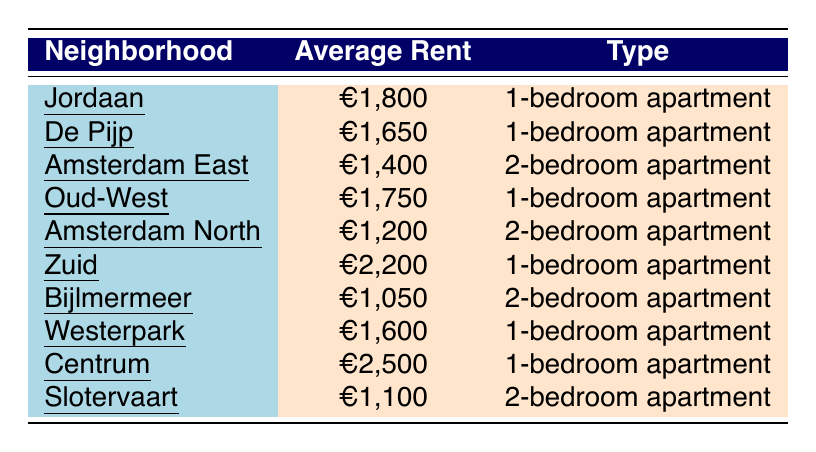What's the average rent for a 1-bedroom apartment in Jordaan? The table shows that the average rent for a 1-bedroom apartment in Jordaan is €1,800.
Answer: €1,800 Which neighborhood has the highest average rent for a 1-bedroom apartment? From the table, the neighborhood with the highest average rent for a 1-bedroom apartment is Centrum at €2,500.
Answer: Centrum What is the average rent of 2-bedroom apartments in Amsterdam North and Bijlmermeer? The average rent for a 2-bedroom apartment in Amsterdam North is €1,200, and in Bijlmermeer, it is €1,050. Adding these gives €1,200 + €1,050 = €2,250 for both, and dividing by 2 gives the average of €1,125.
Answer: €1,125 Is the average rent for a 1-bedroom apartment in De Pijp lower than in Oud-West? The average rent in De Pijp is €1,650 and in Oud-West is €1,750. Since €1,650 is less than €1,750, the statement is true.
Answer: Yes Which two neighborhoods have the lowest average rent for 2-bedroom apartments? The table shows that Bijlmermeer has the lowest rent at €1,050, and Slotervaart has €1,100. Comparing these prices, Bijlmermeer is lower than Slotervaart.
Answer: Bijlmermeer and Slotervaart What is the difference in average rent between the highest and lowest 1-bedroom apartment prices in the neighborhoods? The highest rent for a 1-bedroom apartment is in Centrum at €2,500, and the lowest is in De Pijp at €1,650. The difference is calculated as €2,500 - €1,650 = €850.
Answer: €850 How much more expensive is the average rent for a 1-bedroom apartment in Zuid compared to Amsterdam North's 2-bedroom apartment? The average rent for a 1-bedroom apartment in Zuid is €2,200, and for a 2-bedroom apartment in Amsterdam North, it's €1,200. The difference is €2,200 - €1,200 = €1,000.
Answer: €1,000 What percentage of the average rents for a 1-bedroom apartment is the average rent in Westerpark? The average rent in Westerpark is €1,600. The highest average rent for 1-bedroom apartments is €2,500 in Centrum. The percentage is calculated as (€1,600 / €2,500) * 100 = 64%.
Answer: 64% Are there more neighborhoods with 1-bedroom apartments costing over €1,600 or under €1,600? The neighborhoods with 1-bedroom apartments over €1,600 are Jordaan, Oud-West, Zuid, and Centrum (4). The neighborhoods under €1,600 are De Pijp and Westerpark (2). There are more neighborhoods over €1,600.
Answer: Over €1,600 